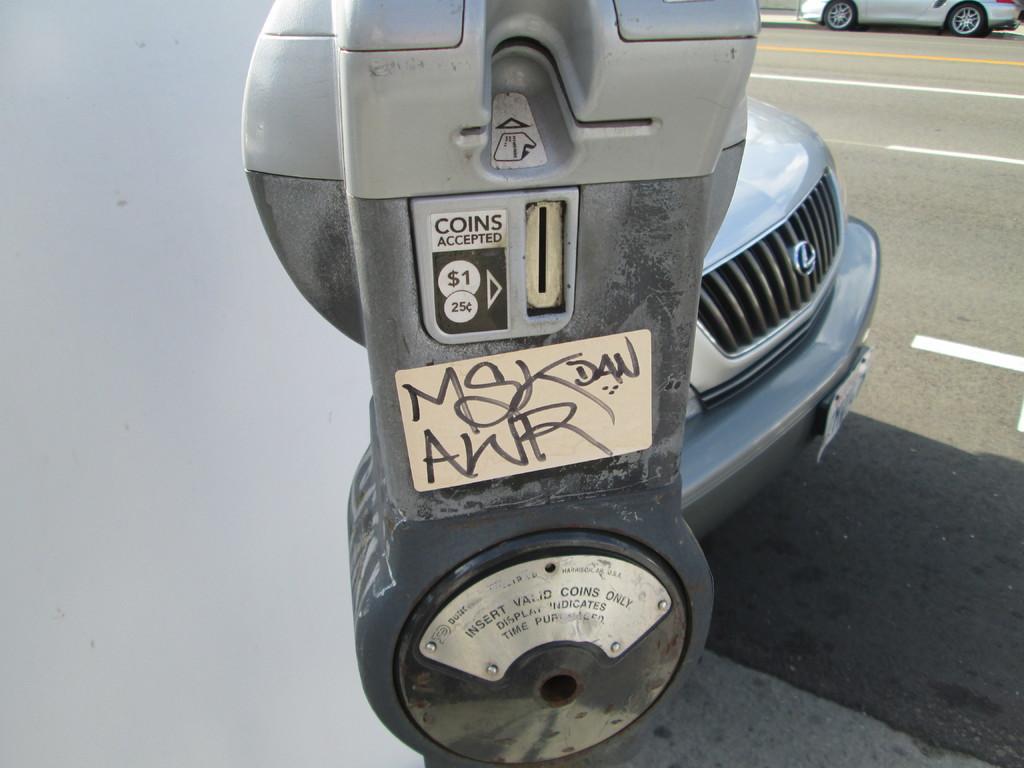What is accepted?
Provide a succinct answer. Coins. Should you use valid or invalid coins?
Provide a succinct answer. Valid. 